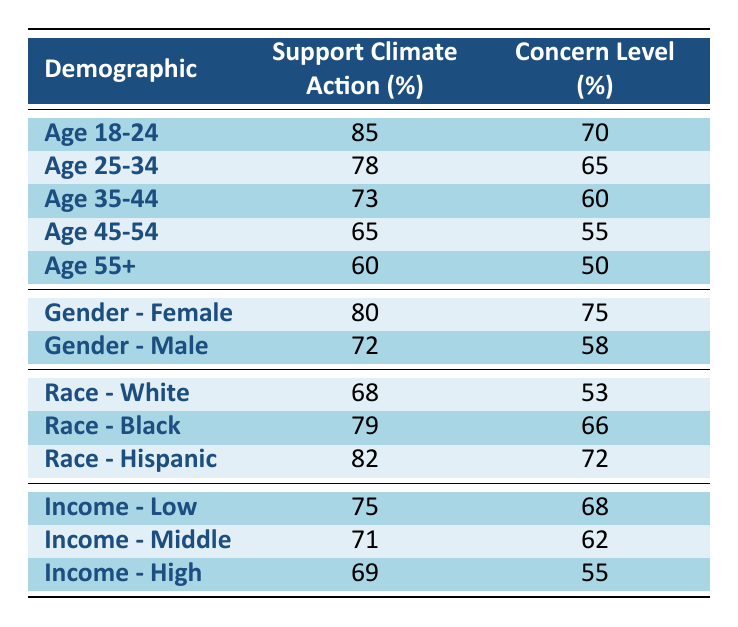What percentage of the demographic aged 18-24 supports climate action? The table states that the demographic "Age 18-24" has a support for climate action of 85%.
Answer: 85% Which demographic has the lowest concern level for climate change? In the table, "Age 55+" has the lowest concern level at 50%.
Answer: Age 55+ What is the average support for climate action among the racial demographics presented (White, Black, Hispanic)? The support percentages for White (68%), Black (79%), and Hispanic (82%) are summed: 68 + 79 + 82 = 229. There are three demographics, so the average is 229 / 3 = 76.33 (rounded to 76%).
Answer: 76% Is the percentage of females supporting climate action higher than that of males? The table shows 80% for females and 72% for males, confirming that females have a higher percentage.
Answer: Yes How much more concerned are females compared to males about climate change? The concern level for females is 75%, and for males, it is 58%. The difference is 75 - 58 = 17%.
Answer: 17% What demographic has a higher support for climate action: Age 25-34 or Race - Black? Age 25-34 has 78% support, while Race - Black has 79%. The percentage for Race - Black is higher.
Answer: Race - Black Which income group shows the highest percentage of support for climate action? The table shows Low Income at 75%, Middle Income at 71%, and High Income at 69%, so Low Income has the highest percentage.
Answer: Low Income What is the difference in climate action support between the age groups 18-24 and 55+? Age 18-24 has 85% support, while Age 55+ has 60%. The difference is 85 - 60 = 25%.
Answer: 25% Are individuals from the demographic of Age 35-44 more concerned about climate change than those aged 45-54? Age 35-44 has a concern level of 60%, while Age 45-54 has 55%, indicating that the 35-44 age group is more concerned.
Answer: Yes What is the total support for climate action from the two youngest age groups? The two youngest groups are Age 18-24 (85%) and Age 25-34 (78%). The total support is 85 + 78 = 163%.
Answer: 163% 